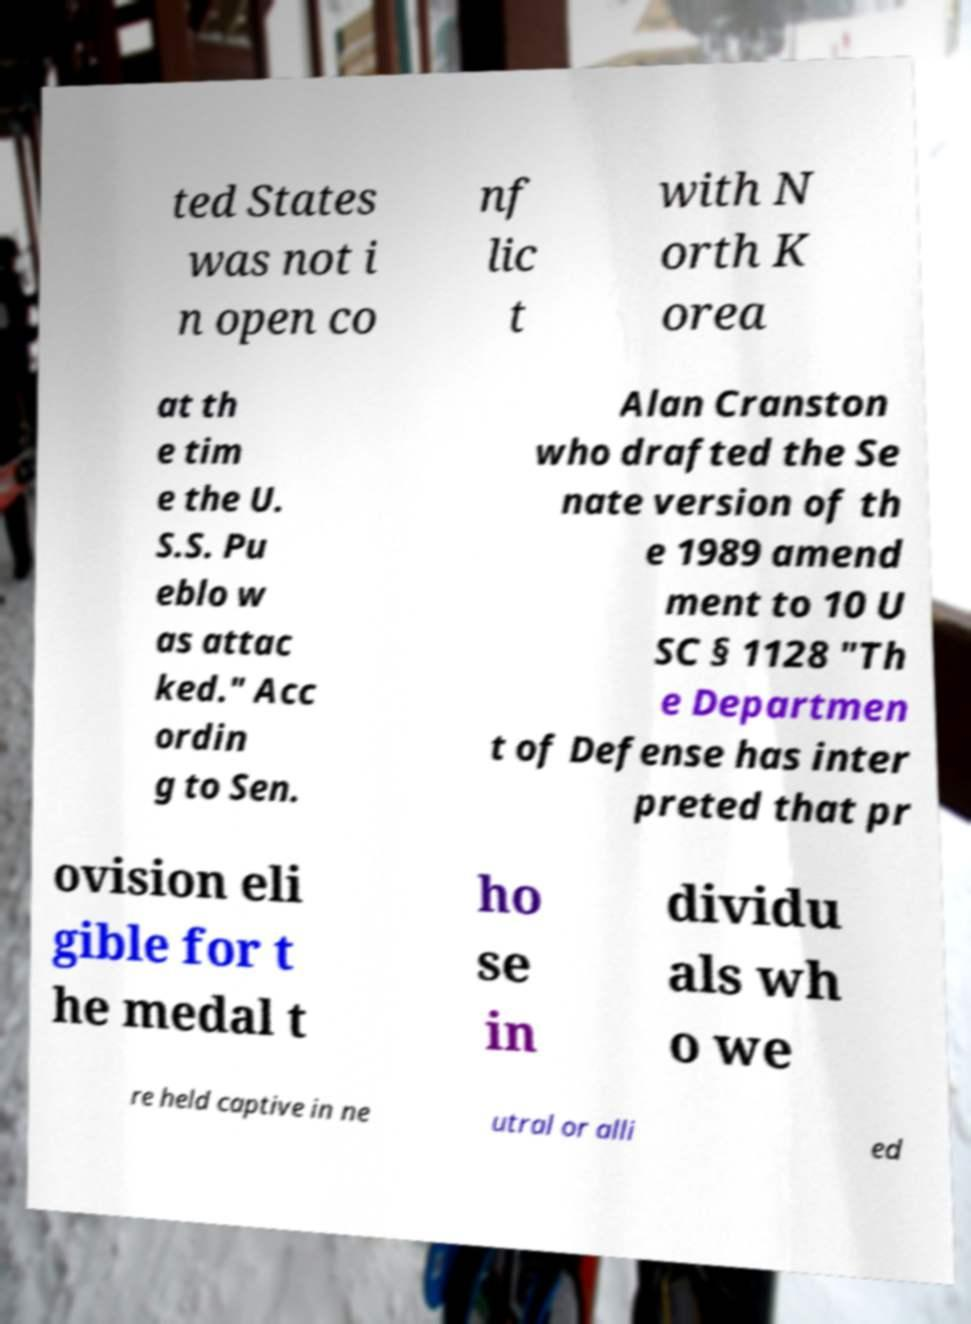Could you extract and type out the text from this image? ted States was not i n open co nf lic t with N orth K orea at th e tim e the U. S.S. Pu eblo w as attac ked." Acc ordin g to Sen. Alan Cranston who drafted the Se nate version of th e 1989 amend ment to 10 U SC § 1128 "Th e Departmen t of Defense has inter preted that pr ovision eli gible for t he medal t ho se in dividu als wh o we re held captive in ne utral or alli ed 